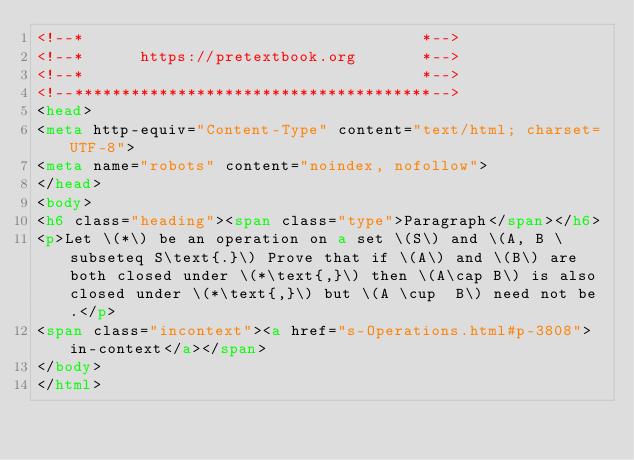<code> <loc_0><loc_0><loc_500><loc_500><_HTML_><!--*                                    *-->
<!--*      https://pretextbook.org       *-->
<!--*                                    *-->
<!--**************************************-->
<head>
<meta http-equiv="Content-Type" content="text/html; charset=UTF-8">
<meta name="robots" content="noindex, nofollow">
</head>
<body>
<h6 class="heading"><span class="type">Paragraph</span></h6>
<p>Let \(*\) be an operation on a set \(S\) and \(A, B \subseteq S\text{.}\) Prove that if \(A\) and \(B\) are both closed under \(*\text{,}\) then \(A\cap B\) is also closed under \(*\text{,}\) but \(A \cup  B\) need not be.</p>
<span class="incontext"><a href="s-Operations.html#p-3808">in-context</a></span>
</body>
</html>
</code> 